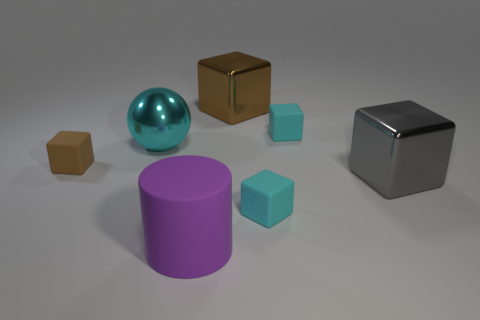There is a cyan rubber block that is in front of the small rubber block that is left of the cylinder; how many metallic things are in front of it?
Offer a very short reply. 0. The brown object behind the brown rubber thing has what shape?
Make the answer very short. Cube. How many other objects are the same material as the gray object?
Provide a short and direct response. 2. Does the big matte cylinder have the same color as the large shiny sphere?
Provide a short and direct response. No. Are there fewer cyan metallic things that are in front of the purple thing than large gray shiny things that are to the left of the gray thing?
Give a very brief answer. No. There is another metallic thing that is the same shape as the big brown metal thing; what color is it?
Keep it short and to the point. Gray. Does the purple matte cylinder right of the brown rubber cube have the same size as the big cyan thing?
Keep it short and to the point. Yes. Is the number of brown things that are left of the large rubber thing less than the number of big cylinders?
Ensure brevity in your answer.  No. Are there any other things that are the same size as the sphere?
Offer a very short reply. Yes. What size is the cyan matte cube that is behind the large cube that is in front of the brown metallic block?
Your response must be concise. Small. 